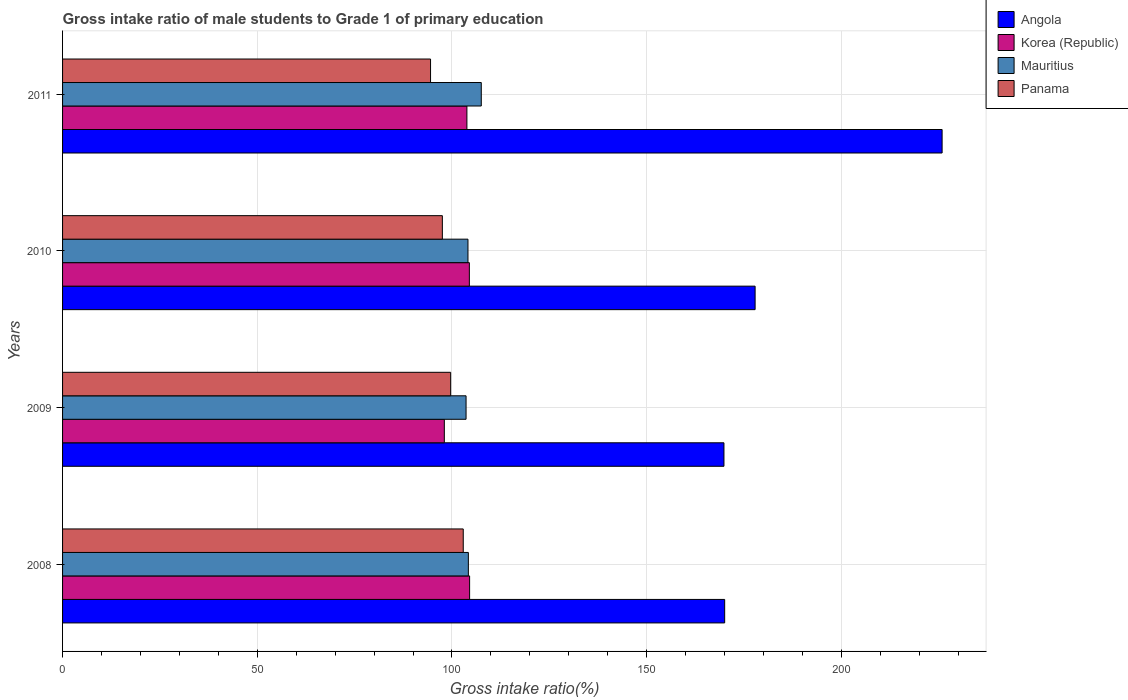How many bars are there on the 1st tick from the top?
Make the answer very short. 4. What is the label of the 2nd group of bars from the top?
Your response must be concise. 2010. In how many cases, is the number of bars for a given year not equal to the number of legend labels?
Provide a succinct answer. 0. What is the gross intake ratio in Angola in 2011?
Your answer should be very brief. 225.89. Across all years, what is the maximum gross intake ratio in Mauritius?
Provide a short and direct response. 107.54. Across all years, what is the minimum gross intake ratio in Panama?
Offer a terse response. 94.51. In which year was the gross intake ratio in Korea (Republic) maximum?
Provide a short and direct response. 2008. What is the total gross intake ratio in Mauritius in the graph?
Your answer should be compact. 419.5. What is the difference between the gross intake ratio in Korea (Republic) in 2010 and that in 2011?
Provide a short and direct response. 0.63. What is the difference between the gross intake ratio in Panama in 2010 and the gross intake ratio in Korea (Republic) in 2009?
Keep it short and to the point. -0.5. What is the average gross intake ratio in Mauritius per year?
Offer a very short reply. 104.88. In the year 2010, what is the difference between the gross intake ratio in Angola and gross intake ratio in Panama?
Ensure brevity in your answer.  80.32. What is the ratio of the gross intake ratio in Mauritius in 2008 to that in 2010?
Your answer should be compact. 1. Is the gross intake ratio in Korea (Republic) in 2008 less than that in 2010?
Make the answer very short. No. Is the difference between the gross intake ratio in Angola in 2008 and 2011 greater than the difference between the gross intake ratio in Panama in 2008 and 2011?
Your answer should be compact. No. What is the difference between the highest and the second highest gross intake ratio in Panama?
Give a very brief answer. 3.23. What is the difference between the highest and the lowest gross intake ratio in Angola?
Offer a terse response. 56.03. In how many years, is the gross intake ratio in Angola greater than the average gross intake ratio in Angola taken over all years?
Make the answer very short. 1. Is the sum of the gross intake ratio in Korea (Republic) in 2008 and 2011 greater than the maximum gross intake ratio in Angola across all years?
Keep it short and to the point. No. Is it the case that in every year, the sum of the gross intake ratio in Panama and gross intake ratio in Mauritius is greater than the sum of gross intake ratio in Angola and gross intake ratio in Korea (Republic)?
Ensure brevity in your answer.  Yes. What does the 2nd bar from the top in 2010 represents?
Provide a short and direct response. Mauritius. What does the 1st bar from the bottom in 2010 represents?
Your response must be concise. Angola. How many bars are there?
Your answer should be very brief. 16. Are all the bars in the graph horizontal?
Provide a succinct answer. Yes. How many years are there in the graph?
Provide a succinct answer. 4. Are the values on the major ticks of X-axis written in scientific E-notation?
Your answer should be compact. No. Does the graph contain any zero values?
Provide a succinct answer. No. Does the graph contain grids?
Keep it short and to the point. Yes. How many legend labels are there?
Provide a succinct answer. 4. What is the title of the graph?
Offer a very short reply. Gross intake ratio of male students to Grade 1 of primary education. Does "Rwanda" appear as one of the legend labels in the graph?
Your answer should be compact. No. What is the label or title of the X-axis?
Your answer should be compact. Gross intake ratio(%). What is the Gross intake ratio(%) in Angola in 2008?
Make the answer very short. 170.04. What is the Gross intake ratio(%) in Korea (Republic) in 2008?
Provide a short and direct response. 104.54. What is the Gross intake ratio(%) in Mauritius in 2008?
Your answer should be very brief. 104.22. What is the Gross intake ratio(%) of Panama in 2008?
Make the answer very short. 102.9. What is the Gross intake ratio(%) of Angola in 2009?
Offer a very short reply. 169.86. What is the Gross intake ratio(%) in Korea (Republic) in 2009?
Make the answer very short. 98.04. What is the Gross intake ratio(%) in Mauritius in 2009?
Offer a very short reply. 103.63. What is the Gross intake ratio(%) in Panama in 2009?
Your answer should be very brief. 99.67. What is the Gross intake ratio(%) of Angola in 2010?
Offer a terse response. 177.86. What is the Gross intake ratio(%) of Korea (Republic) in 2010?
Ensure brevity in your answer.  104.47. What is the Gross intake ratio(%) in Mauritius in 2010?
Give a very brief answer. 104.12. What is the Gross intake ratio(%) in Panama in 2010?
Your response must be concise. 97.54. What is the Gross intake ratio(%) of Angola in 2011?
Your answer should be compact. 225.89. What is the Gross intake ratio(%) in Korea (Republic) in 2011?
Provide a short and direct response. 103.84. What is the Gross intake ratio(%) in Mauritius in 2011?
Your answer should be very brief. 107.54. What is the Gross intake ratio(%) of Panama in 2011?
Provide a succinct answer. 94.51. Across all years, what is the maximum Gross intake ratio(%) of Angola?
Make the answer very short. 225.89. Across all years, what is the maximum Gross intake ratio(%) in Korea (Republic)?
Ensure brevity in your answer.  104.54. Across all years, what is the maximum Gross intake ratio(%) in Mauritius?
Make the answer very short. 107.54. Across all years, what is the maximum Gross intake ratio(%) in Panama?
Provide a succinct answer. 102.9. Across all years, what is the minimum Gross intake ratio(%) in Angola?
Your response must be concise. 169.86. Across all years, what is the minimum Gross intake ratio(%) of Korea (Republic)?
Provide a succinct answer. 98.04. Across all years, what is the minimum Gross intake ratio(%) in Mauritius?
Your answer should be very brief. 103.63. Across all years, what is the minimum Gross intake ratio(%) in Panama?
Your answer should be very brief. 94.51. What is the total Gross intake ratio(%) of Angola in the graph?
Keep it short and to the point. 743.66. What is the total Gross intake ratio(%) in Korea (Republic) in the graph?
Give a very brief answer. 410.9. What is the total Gross intake ratio(%) in Mauritius in the graph?
Ensure brevity in your answer.  419.5. What is the total Gross intake ratio(%) of Panama in the graph?
Offer a very short reply. 394.63. What is the difference between the Gross intake ratio(%) in Angola in 2008 and that in 2009?
Your response must be concise. 0.18. What is the difference between the Gross intake ratio(%) in Korea (Republic) in 2008 and that in 2009?
Your answer should be very brief. 6.5. What is the difference between the Gross intake ratio(%) of Mauritius in 2008 and that in 2009?
Your answer should be very brief. 0.59. What is the difference between the Gross intake ratio(%) of Panama in 2008 and that in 2009?
Make the answer very short. 3.23. What is the difference between the Gross intake ratio(%) in Angola in 2008 and that in 2010?
Provide a short and direct response. -7.82. What is the difference between the Gross intake ratio(%) of Korea (Republic) in 2008 and that in 2010?
Provide a succinct answer. 0.07. What is the difference between the Gross intake ratio(%) of Mauritius in 2008 and that in 2010?
Your answer should be compact. 0.1. What is the difference between the Gross intake ratio(%) of Panama in 2008 and that in 2010?
Offer a terse response. 5.36. What is the difference between the Gross intake ratio(%) in Angola in 2008 and that in 2011?
Make the answer very short. -55.85. What is the difference between the Gross intake ratio(%) in Korea (Republic) in 2008 and that in 2011?
Offer a terse response. 0.7. What is the difference between the Gross intake ratio(%) of Mauritius in 2008 and that in 2011?
Ensure brevity in your answer.  -3.32. What is the difference between the Gross intake ratio(%) of Panama in 2008 and that in 2011?
Your answer should be compact. 8.4. What is the difference between the Gross intake ratio(%) in Angola in 2009 and that in 2010?
Give a very brief answer. -8. What is the difference between the Gross intake ratio(%) in Korea (Republic) in 2009 and that in 2010?
Provide a succinct answer. -6.43. What is the difference between the Gross intake ratio(%) of Mauritius in 2009 and that in 2010?
Make the answer very short. -0.49. What is the difference between the Gross intake ratio(%) of Panama in 2009 and that in 2010?
Your answer should be very brief. 2.13. What is the difference between the Gross intake ratio(%) in Angola in 2009 and that in 2011?
Offer a very short reply. -56.03. What is the difference between the Gross intake ratio(%) of Korea (Republic) in 2009 and that in 2011?
Provide a succinct answer. -5.8. What is the difference between the Gross intake ratio(%) in Mauritius in 2009 and that in 2011?
Keep it short and to the point. -3.91. What is the difference between the Gross intake ratio(%) in Panama in 2009 and that in 2011?
Provide a short and direct response. 5.17. What is the difference between the Gross intake ratio(%) in Angola in 2010 and that in 2011?
Give a very brief answer. -48.03. What is the difference between the Gross intake ratio(%) in Korea (Republic) in 2010 and that in 2011?
Give a very brief answer. 0.63. What is the difference between the Gross intake ratio(%) of Mauritius in 2010 and that in 2011?
Keep it short and to the point. -3.42. What is the difference between the Gross intake ratio(%) of Panama in 2010 and that in 2011?
Offer a terse response. 3.04. What is the difference between the Gross intake ratio(%) of Angola in 2008 and the Gross intake ratio(%) of Korea (Republic) in 2009?
Your answer should be very brief. 72. What is the difference between the Gross intake ratio(%) of Angola in 2008 and the Gross intake ratio(%) of Mauritius in 2009?
Keep it short and to the point. 66.41. What is the difference between the Gross intake ratio(%) of Angola in 2008 and the Gross intake ratio(%) of Panama in 2009?
Provide a short and direct response. 70.37. What is the difference between the Gross intake ratio(%) in Korea (Republic) in 2008 and the Gross intake ratio(%) in Mauritius in 2009?
Make the answer very short. 0.91. What is the difference between the Gross intake ratio(%) in Korea (Republic) in 2008 and the Gross intake ratio(%) in Panama in 2009?
Make the answer very short. 4.87. What is the difference between the Gross intake ratio(%) in Mauritius in 2008 and the Gross intake ratio(%) in Panama in 2009?
Your answer should be very brief. 4.54. What is the difference between the Gross intake ratio(%) in Angola in 2008 and the Gross intake ratio(%) in Korea (Republic) in 2010?
Make the answer very short. 65.57. What is the difference between the Gross intake ratio(%) of Angola in 2008 and the Gross intake ratio(%) of Mauritius in 2010?
Offer a very short reply. 65.93. What is the difference between the Gross intake ratio(%) of Angola in 2008 and the Gross intake ratio(%) of Panama in 2010?
Your answer should be compact. 72.5. What is the difference between the Gross intake ratio(%) of Korea (Republic) in 2008 and the Gross intake ratio(%) of Mauritius in 2010?
Ensure brevity in your answer.  0.42. What is the difference between the Gross intake ratio(%) in Korea (Republic) in 2008 and the Gross intake ratio(%) in Panama in 2010?
Your response must be concise. 7. What is the difference between the Gross intake ratio(%) of Mauritius in 2008 and the Gross intake ratio(%) of Panama in 2010?
Ensure brevity in your answer.  6.68. What is the difference between the Gross intake ratio(%) in Angola in 2008 and the Gross intake ratio(%) in Korea (Republic) in 2011?
Provide a succinct answer. 66.2. What is the difference between the Gross intake ratio(%) in Angola in 2008 and the Gross intake ratio(%) in Mauritius in 2011?
Make the answer very short. 62.51. What is the difference between the Gross intake ratio(%) of Angola in 2008 and the Gross intake ratio(%) of Panama in 2011?
Keep it short and to the point. 75.54. What is the difference between the Gross intake ratio(%) in Korea (Republic) in 2008 and the Gross intake ratio(%) in Mauritius in 2011?
Make the answer very short. -3. What is the difference between the Gross intake ratio(%) of Korea (Republic) in 2008 and the Gross intake ratio(%) of Panama in 2011?
Give a very brief answer. 10.03. What is the difference between the Gross intake ratio(%) in Mauritius in 2008 and the Gross intake ratio(%) in Panama in 2011?
Offer a terse response. 9.71. What is the difference between the Gross intake ratio(%) in Angola in 2009 and the Gross intake ratio(%) in Korea (Republic) in 2010?
Make the answer very short. 65.39. What is the difference between the Gross intake ratio(%) in Angola in 2009 and the Gross intake ratio(%) in Mauritius in 2010?
Give a very brief answer. 65.74. What is the difference between the Gross intake ratio(%) in Angola in 2009 and the Gross intake ratio(%) in Panama in 2010?
Your response must be concise. 72.32. What is the difference between the Gross intake ratio(%) in Korea (Republic) in 2009 and the Gross intake ratio(%) in Mauritius in 2010?
Offer a very short reply. -6.07. What is the difference between the Gross intake ratio(%) in Korea (Republic) in 2009 and the Gross intake ratio(%) in Panama in 2010?
Ensure brevity in your answer.  0.5. What is the difference between the Gross intake ratio(%) of Mauritius in 2009 and the Gross intake ratio(%) of Panama in 2010?
Give a very brief answer. 6.09. What is the difference between the Gross intake ratio(%) of Angola in 2009 and the Gross intake ratio(%) of Korea (Republic) in 2011?
Your answer should be compact. 66.02. What is the difference between the Gross intake ratio(%) in Angola in 2009 and the Gross intake ratio(%) in Mauritius in 2011?
Offer a terse response. 62.33. What is the difference between the Gross intake ratio(%) in Angola in 2009 and the Gross intake ratio(%) in Panama in 2011?
Give a very brief answer. 75.36. What is the difference between the Gross intake ratio(%) of Korea (Republic) in 2009 and the Gross intake ratio(%) of Mauritius in 2011?
Provide a short and direct response. -9.49. What is the difference between the Gross intake ratio(%) of Korea (Republic) in 2009 and the Gross intake ratio(%) of Panama in 2011?
Give a very brief answer. 3.54. What is the difference between the Gross intake ratio(%) in Mauritius in 2009 and the Gross intake ratio(%) in Panama in 2011?
Ensure brevity in your answer.  9.12. What is the difference between the Gross intake ratio(%) in Angola in 2010 and the Gross intake ratio(%) in Korea (Republic) in 2011?
Give a very brief answer. 74.02. What is the difference between the Gross intake ratio(%) of Angola in 2010 and the Gross intake ratio(%) of Mauritius in 2011?
Your answer should be very brief. 70.33. What is the difference between the Gross intake ratio(%) of Angola in 2010 and the Gross intake ratio(%) of Panama in 2011?
Keep it short and to the point. 83.36. What is the difference between the Gross intake ratio(%) of Korea (Republic) in 2010 and the Gross intake ratio(%) of Mauritius in 2011?
Offer a terse response. -3.06. What is the difference between the Gross intake ratio(%) of Korea (Republic) in 2010 and the Gross intake ratio(%) of Panama in 2011?
Your answer should be very brief. 9.97. What is the difference between the Gross intake ratio(%) of Mauritius in 2010 and the Gross intake ratio(%) of Panama in 2011?
Ensure brevity in your answer.  9.61. What is the average Gross intake ratio(%) in Angola per year?
Give a very brief answer. 185.91. What is the average Gross intake ratio(%) of Korea (Republic) per year?
Ensure brevity in your answer.  102.73. What is the average Gross intake ratio(%) in Mauritius per year?
Your response must be concise. 104.88. What is the average Gross intake ratio(%) of Panama per year?
Keep it short and to the point. 98.66. In the year 2008, what is the difference between the Gross intake ratio(%) in Angola and Gross intake ratio(%) in Korea (Republic)?
Make the answer very short. 65.5. In the year 2008, what is the difference between the Gross intake ratio(%) of Angola and Gross intake ratio(%) of Mauritius?
Give a very brief answer. 65.83. In the year 2008, what is the difference between the Gross intake ratio(%) in Angola and Gross intake ratio(%) in Panama?
Your response must be concise. 67.14. In the year 2008, what is the difference between the Gross intake ratio(%) in Korea (Republic) and Gross intake ratio(%) in Mauritius?
Offer a terse response. 0.32. In the year 2008, what is the difference between the Gross intake ratio(%) in Korea (Republic) and Gross intake ratio(%) in Panama?
Give a very brief answer. 1.64. In the year 2008, what is the difference between the Gross intake ratio(%) of Mauritius and Gross intake ratio(%) of Panama?
Keep it short and to the point. 1.31. In the year 2009, what is the difference between the Gross intake ratio(%) of Angola and Gross intake ratio(%) of Korea (Republic)?
Your response must be concise. 71.82. In the year 2009, what is the difference between the Gross intake ratio(%) in Angola and Gross intake ratio(%) in Mauritius?
Keep it short and to the point. 66.23. In the year 2009, what is the difference between the Gross intake ratio(%) in Angola and Gross intake ratio(%) in Panama?
Make the answer very short. 70.19. In the year 2009, what is the difference between the Gross intake ratio(%) of Korea (Republic) and Gross intake ratio(%) of Mauritius?
Your answer should be very brief. -5.58. In the year 2009, what is the difference between the Gross intake ratio(%) of Korea (Republic) and Gross intake ratio(%) of Panama?
Your answer should be compact. -1.63. In the year 2009, what is the difference between the Gross intake ratio(%) of Mauritius and Gross intake ratio(%) of Panama?
Provide a short and direct response. 3.96. In the year 2010, what is the difference between the Gross intake ratio(%) in Angola and Gross intake ratio(%) in Korea (Republic)?
Ensure brevity in your answer.  73.39. In the year 2010, what is the difference between the Gross intake ratio(%) in Angola and Gross intake ratio(%) in Mauritius?
Offer a very short reply. 73.74. In the year 2010, what is the difference between the Gross intake ratio(%) in Angola and Gross intake ratio(%) in Panama?
Ensure brevity in your answer.  80.32. In the year 2010, what is the difference between the Gross intake ratio(%) in Korea (Republic) and Gross intake ratio(%) in Mauritius?
Provide a short and direct response. 0.35. In the year 2010, what is the difference between the Gross intake ratio(%) of Korea (Republic) and Gross intake ratio(%) of Panama?
Provide a succinct answer. 6.93. In the year 2010, what is the difference between the Gross intake ratio(%) in Mauritius and Gross intake ratio(%) in Panama?
Keep it short and to the point. 6.58. In the year 2011, what is the difference between the Gross intake ratio(%) in Angola and Gross intake ratio(%) in Korea (Republic)?
Offer a terse response. 122.04. In the year 2011, what is the difference between the Gross intake ratio(%) in Angola and Gross intake ratio(%) in Mauritius?
Offer a terse response. 118.35. In the year 2011, what is the difference between the Gross intake ratio(%) in Angola and Gross intake ratio(%) in Panama?
Make the answer very short. 131.38. In the year 2011, what is the difference between the Gross intake ratio(%) of Korea (Republic) and Gross intake ratio(%) of Mauritius?
Offer a very short reply. -3.69. In the year 2011, what is the difference between the Gross intake ratio(%) of Korea (Republic) and Gross intake ratio(%) of Panama?
Offer a terse response. 9.34. In the year 2011, what is the difference between the Gross intake ratio(%) of Mauritius and Gross intake ratio(%) of Panama?
Offer a very short reply. 13.03. What is the ratio of the Gross intake ratio(%) of Angola in 2008 to that in 2009?
Offer a terse response. 1. What is the ratio of the Gross intake ratio(%) of Korea (Republic) in 2008 to that in 2009?
Your response must be concise. 1.07. What is the ratio of the Gross intake ratio(%) of Mauritius in 2008 to that in 2009?
Offer a very short reply. 1.01. What is the ratio of the Gross intake ratio(%) in Panama in 2008 to that in 2009?
Your answer should be very brief. 1.03. What is the ratio of the Gross intake ratio(%) in Angola in 2008 to that in 2010?
Offer a terse response. 0.96. What is the ratio of the Gross intake ratio(%) in Korea (Republic) in 2008 to that in 2010?
Provide a short and direct response. 1. What is the ratio of the Gross intake ratio(%) in Panama in 2008 to that in 2010?
Offer a very short reply. 1.05. What is the ratio of the Gross intake ratio(%) of Angola in 2008 to that in 2011?
Your response must be concise. 0.75. What is the ratio of the Gross intake ratio(%) in Korea (Republic) in 2008 to that in 2011?
Your answer should be compact. 1.01. What is the ratio of the Gross intake ratio(%) in Mauritius in 2008 to that in 2011?
Offer a very short reply. 0.97. What is the ratio of the Gross intake ratio(%) in Panama in 2008 to that in 2011?
Provide a succinct answer. 1.09. What is the ratio of the Gross intake ratio(%) of Angola in 2009 to that in 2010?
Make the answer very short. 0.95. What is the ratio of the Gross intake ratio(%) in Korea (Republic) in 2009 to that in 2010?
Give a very brief answer. 0.94. What is the ratio of the Gross intake ratio(%) of Panama in 2009 to that in 2010?
Your response must be concise. 1.02. What is the ratio of the Gross intake ratio(%) in Angola in 2009 to that in 2011?
Your answer should be compact. 0.75. What is the ratio of the Gross intake ratio(%) of Korea (Republic) in 2009 to that in 2011?
Your answer should be compact. 0.94. What is the ratio of the Gross intake ratio(%) of Mauritius in 2009 to that in 2011?
Provide a short and direct response. 0.96. What is the ratio of the Gross intake ratio(%) of Panama in 2009 to that in 2011?
Provide a succinct answer. 1.05. What is the ratio of the Gross intake ratio(%) in Angola in 2010 to that in 2011?
Your answer should be very brief. 0.79. What is the ratio of the Gross intake ratio(%) of Mauritius in 2010 to that in 2011?
Your response must be concise. 0.97. What is the ratio of the Gross intake ratio(%) in Panama in 2010 to that in 2011?
Your answer should be very brief. 1.03. What is the difference between the highest and the second highest Gross intake ratio(%) in Angola?
Give a very brief answer. 48.03. What is the difference between the highest and the second highest Gross intake ratio(%) in Korea (Republic)?
Offer a very short reply. 0.07. What is the difference between the highest and the second highest Gross intake ratio(%) in Mauritius?
Your response must be concise. 3.32. What is the difference between the highest and the second highest Gross intake ratio(%) in Panama?
Give a very brief answer. 3.23. What is the difference between the highest and the lowest Gross intake ratio(%) in Angola?
Provide a short and direct response. 56.03. What is the difference between the highest and the lowest Gross intake ratio(%) of Korea (Republic)?
Your answer should be compact. 6.5. What is the difference between the highest and the lowest Gross intake ratio(%) in Mauritius?
Your response must be concise. 3.91. What is the difference between the highest and the lowest Gross intake ratio(%) in Panama?
Make the answer very short. 8.4. 